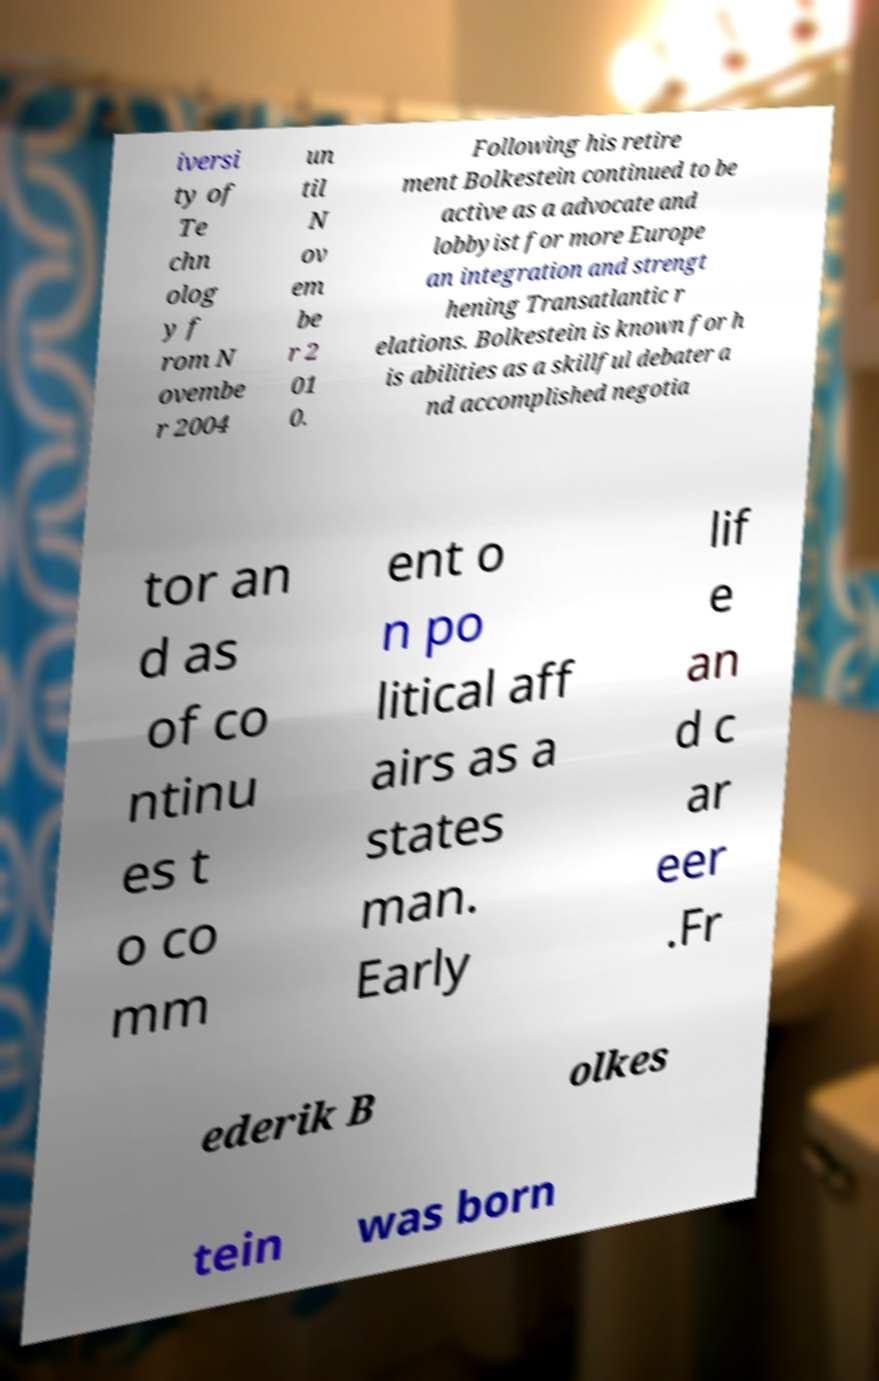Please read and relay the text visible in this image. What does it say? iversi ty of Te chn olog y f rom N ovembe r 2004 un til N ov em be r 2 01 0. Following his retire ment Bolkestein continued to be active as a advocate and lobbyist for more Europe an integration and strengt hening Transatlantic r elations. Bolkestein is known for h is abilities as a skillful debater a nd accomplished negotia tor an d as of co ntinu es t o co mm ent o n po litical aff airs as a states man. Early lif e an d c ar eer .Fr ederik B olkes tein was born 